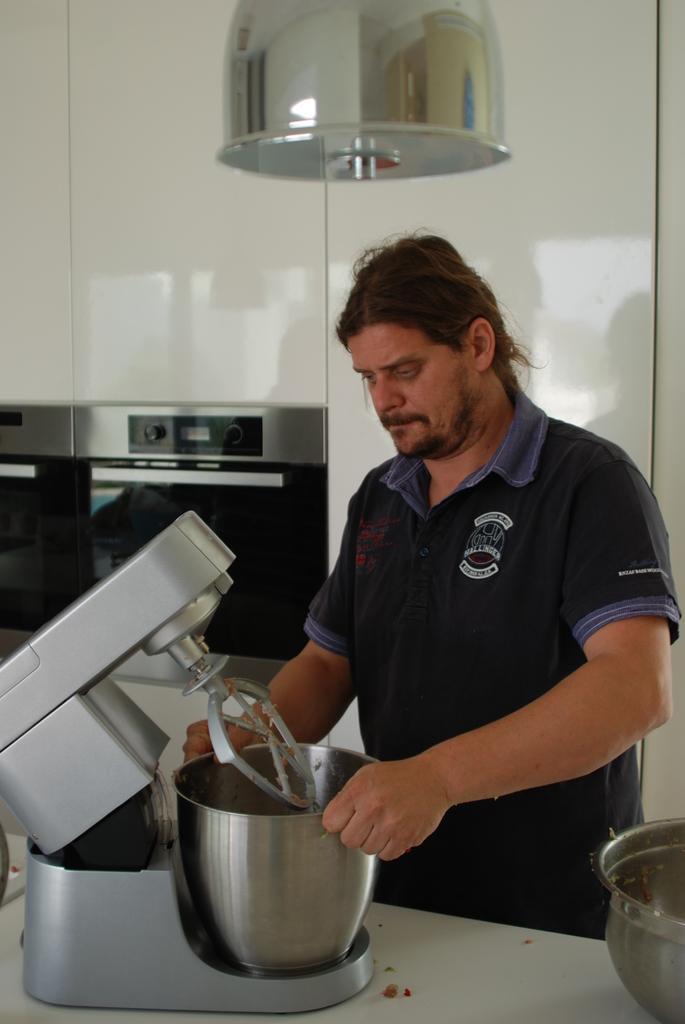How would you summarize this image in a sentence or two? There is a man holding a mixing machine. It is on a table. On the right side there is a vessel on the table. In the back there is a white wall with some electronic item. 